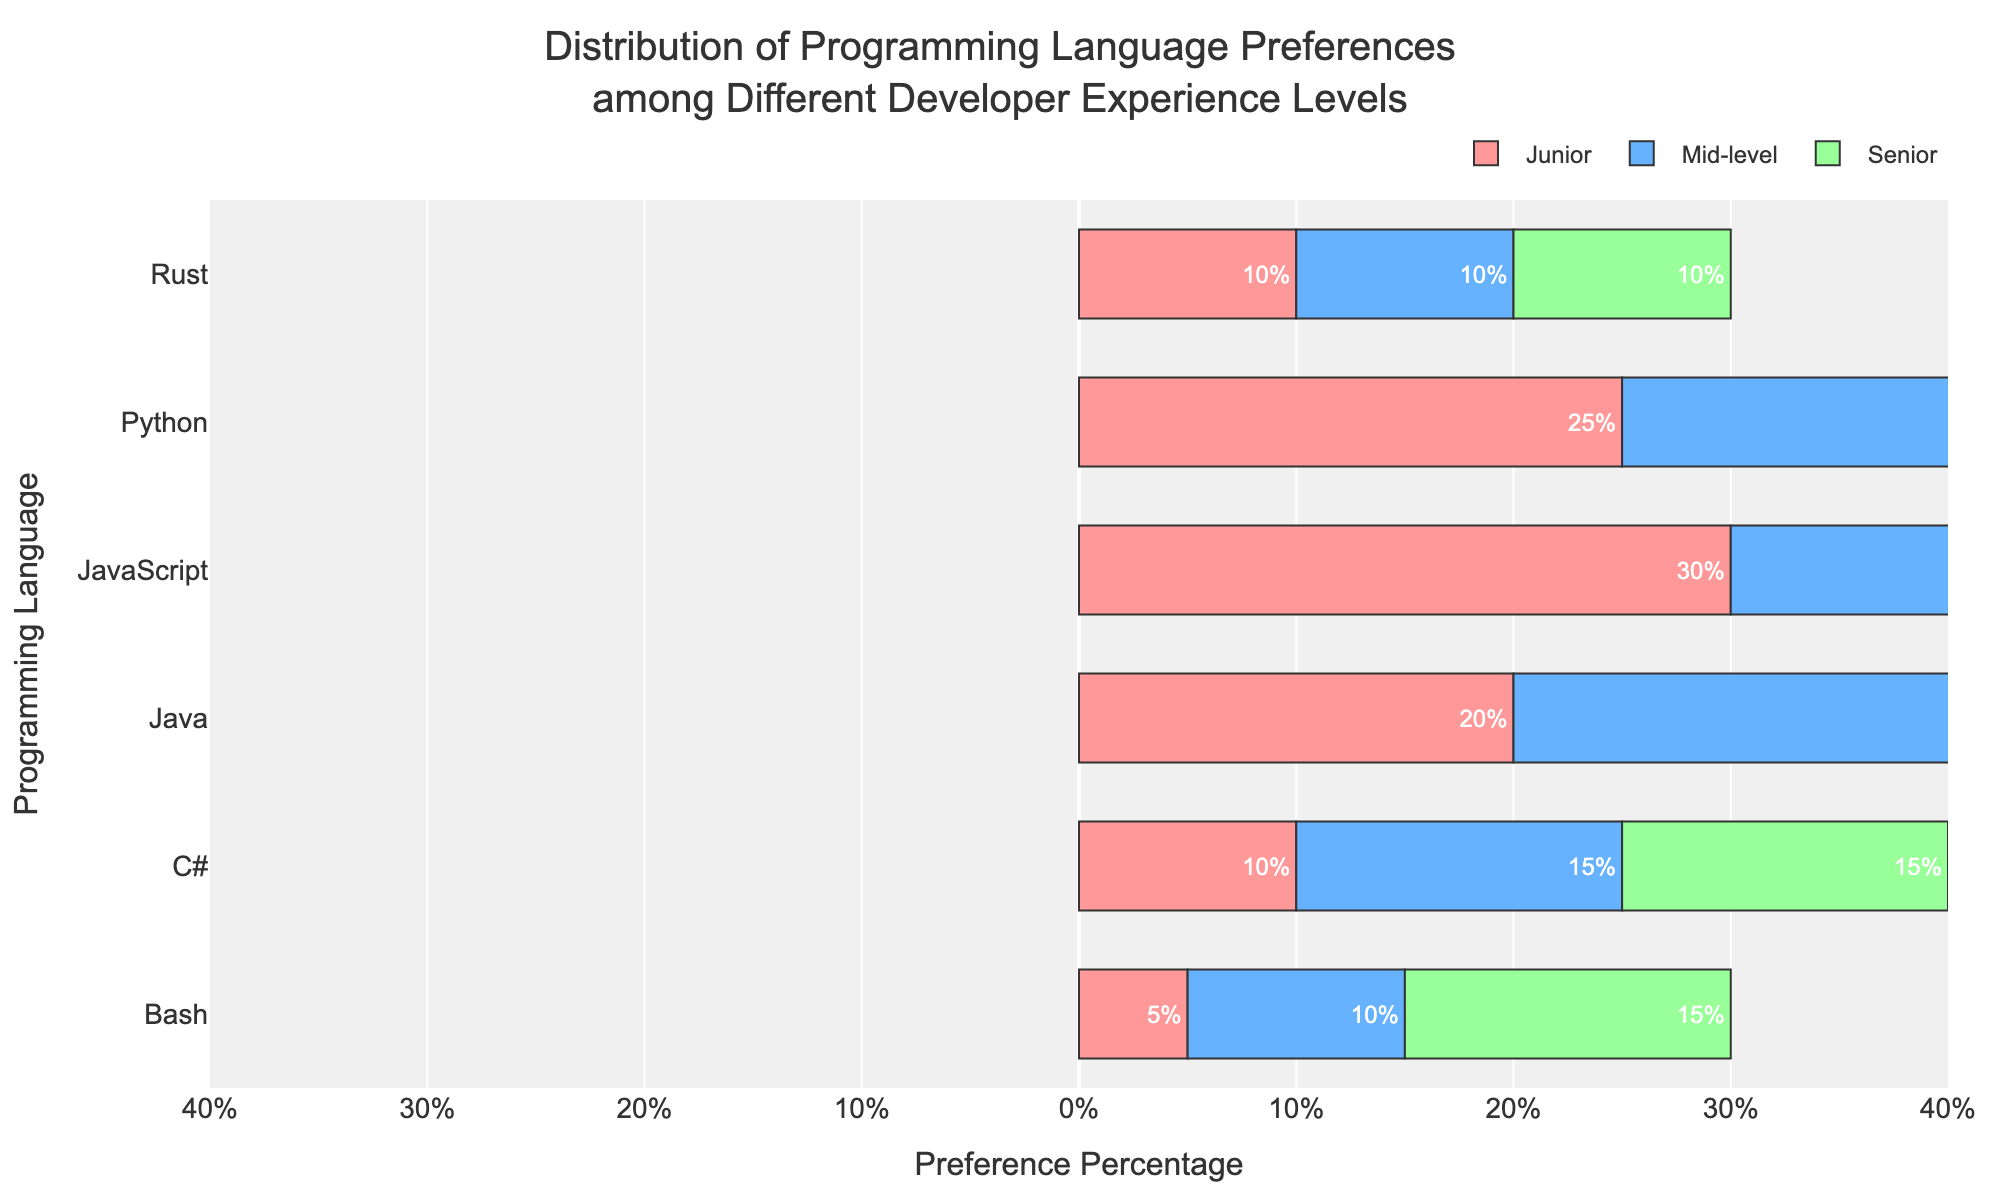Which programming language has the highest preference among Junior developers? Junior developers prefer JavaScript the most, as evidenced by the longest bar in the Junior category corresponding to JavaScript at 30%.
Answer: JavaScript Which programming language shows the smallest difference in preference percentage between Junior and Senior developers? The difference for Rust is zero as both Junior and Senior developers have a 10% preference for it, showing no change.
Answer: Rust How much higher is the preference for Java among Senior developers compared to Mid-level developers? Senior developers have a 40% preference for Java, whereas Mid-level developers have a 30% preference. The difference is calculated as 40% - 30% = 10%.
Answer: 10% What's the total preference percentage for Bash across all experience levels? Sum the preference percentages of Bash for Junior (5%), Mid-level (10%), and Senior (15%) developers, resulting in 5% + 10% + 15% = 30%.
Answer: 30% Which experience level has the highest preference for C#? Senior developers have a 15% preference for C#, the highest among experience levels, as seen by the longest bar for C# in the Senior category.
Answer: Senior Which language has the most significant drop in preference from Junior to Senior developers? Python shows the most significant drop from 25% to 10%, calculated as 25% - 10% = 15%.
Answer: Python Identify a programming language that has a consistent preference percentage across Mid-level and one other experience level. Rust has consistent preferences between Mid-level and Senior developers, both at 10%.
Answer: Rust By how many percentage points does the preference for Java among Junior developers differ from Senior developers? Junior developers have a 20% preference, while Senior developers have a 40% preference for Java. The difference is 40% - 20% = 20%.
Answer: 20% Which experience level has the lowest overall variation in programming language preferences? Mid-level shows the least variation in bar lengths across different programming languages, indicating a more evenly spread preference distribution.
Answer: Mid-level Compare the preference trend for Bash and JavaScript for all experience levels. Bash shows an increasing preference from Junior (5%) to Senior (15%), while JavaScript shows a decreasing trend from Junior (30%) to Senior (10%).
Answer: Bash increases, JavaScript decreases 